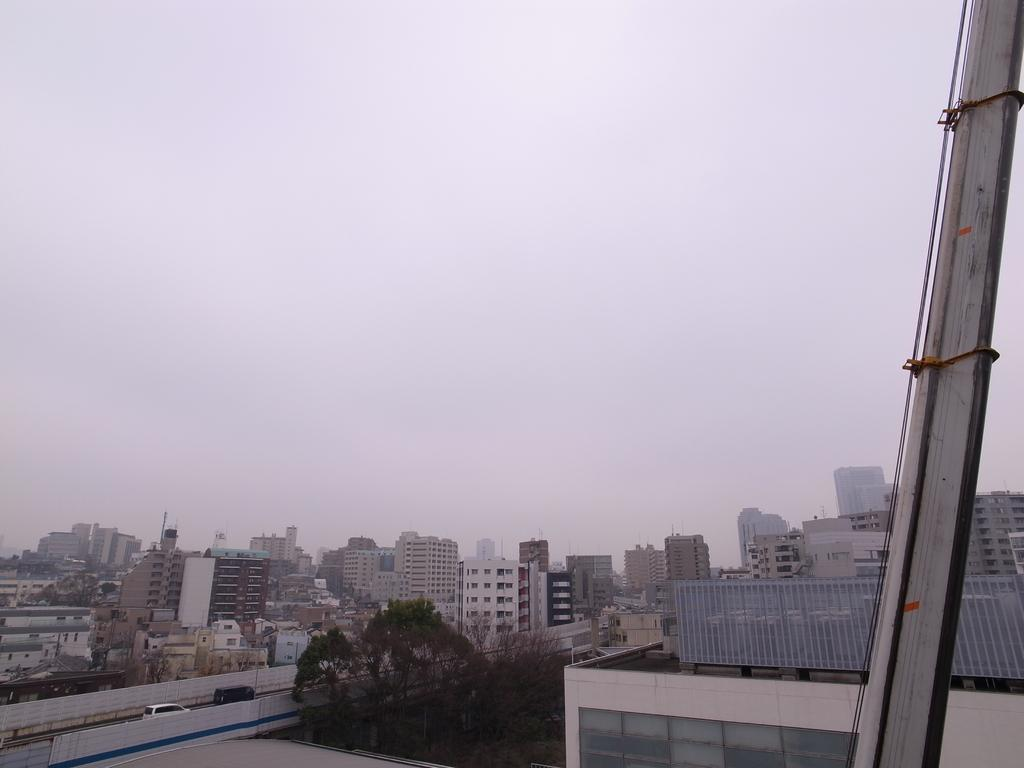What type of structures can be seen in the image? There are buildings in the image. What natural elements are present in the image? There are trees in the image. What man-made objects can be seen in the image? There are vehicles in the image. What is visible at the top of the image? Clouds and the sky are visible at the top of the image. Are there any bears visible in the image? No, there are no bears present in the image. What shape is the dock in the image? There is no dock present in the image. 